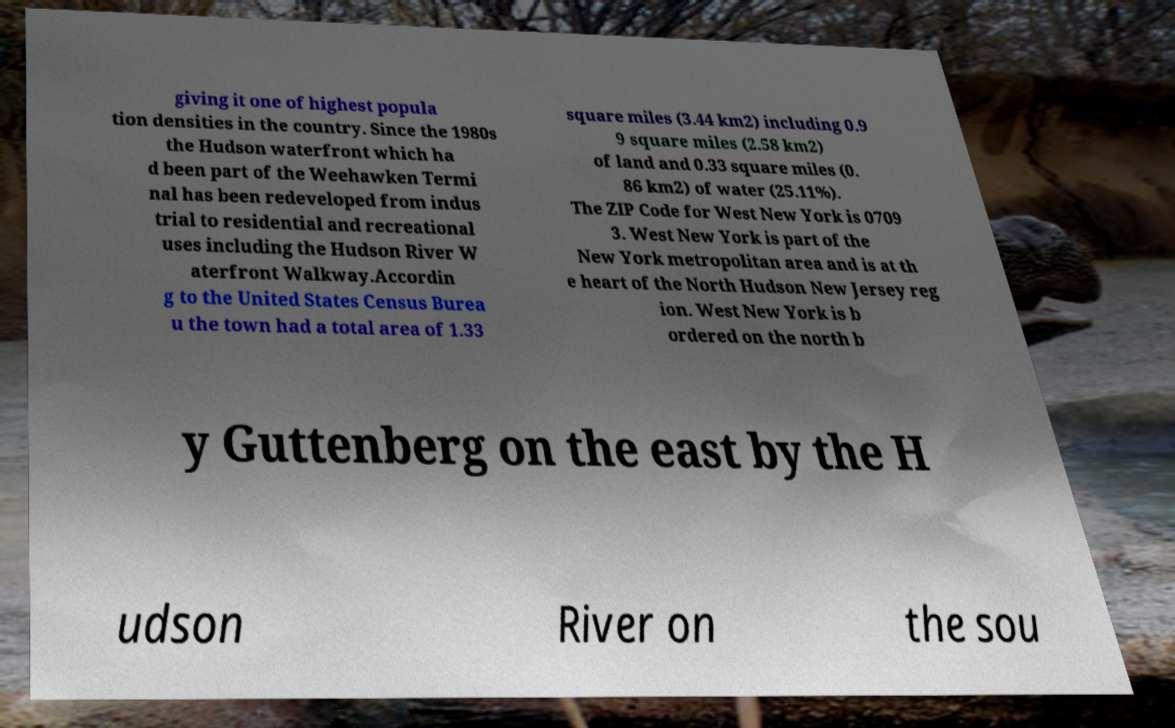Please identify and transcribe the text found in this image. giving it one of highest popula tion densities in the country. Since the 1980s the Hudson waterfront which ha d been part of the Weehawken Termi nal has been redeveloped from indus trial to residential and recreational uses including the Hudson River W aterfront Walkway.Accordin g to the United States Census Burea u the town had a total area of 1.33 square miles (3.44 km2) including 0.9 9 square miles (2.58 km2) of land and 0.33 square miles (0. 86 km2) of water (25.11%). The ZIP Code for West New York is 0709 3. West New York is part of the New York metropolitan area and is at th e heart of the North Hudson New Jersey reg ion. West New York is b ordered on the north b y Guttenberg on the east by the H udson River on the sou 